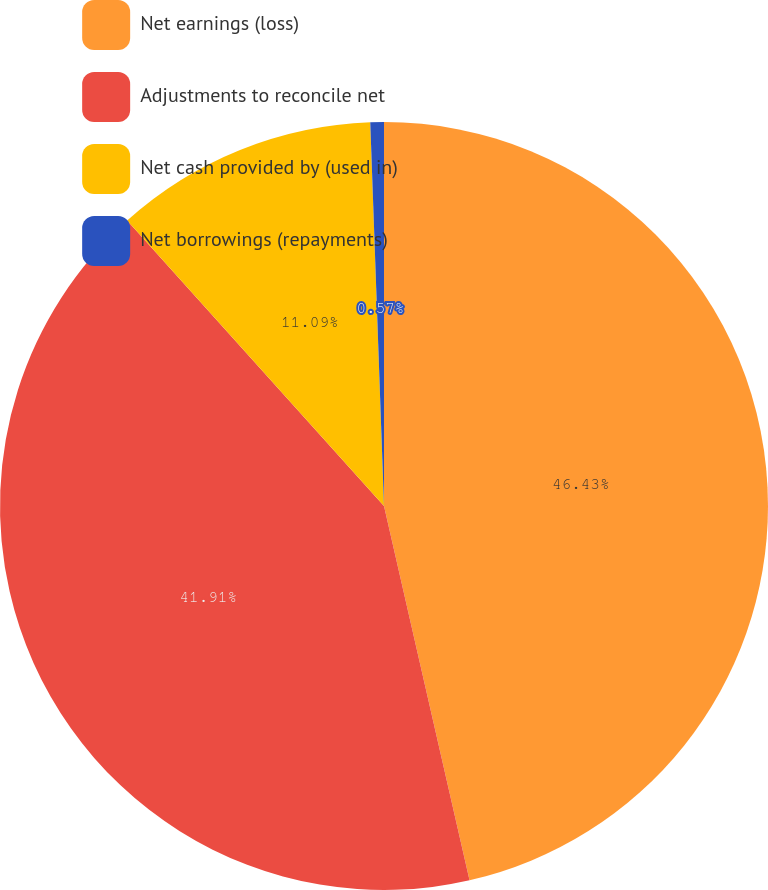Convert chart. <chart><loc_0><loc_0><loc_500><loc_500><pie_chart><fcel>Net earnings (loss)<fcel>Adjustments to reconcile net<fcel>Net cash provided by (used in)<fcel>Net borrowings (repayments)<nl><fcel>46.42%<fcel>41.91%<fcel>11.09%<fcel>0.57%<nl></chart> 